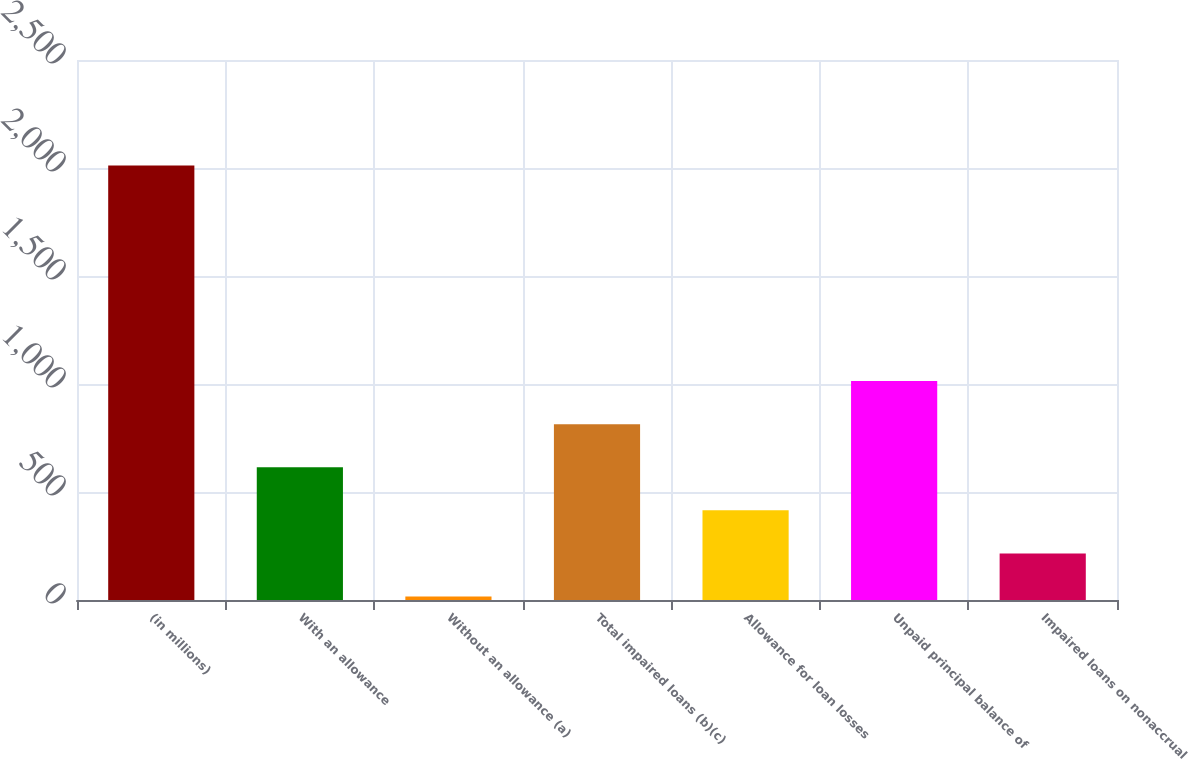Convert chart to OTSL. <chart><loc_0><loc_0><loc_500><loc_500><bar_chart><fcel>(in millions)<fcel>With an allowance<fcel>Without an allowance (a)<fcel>Total impaired loans (b)(c)<fcel>Allowance for loan losses<fcel>Unpaid principal balance of<fcel>Impaired loans on nonaccrual<nl><fcel>2011<fcel>614.5<fcel>16<fcel>814<fcel>415<fcel>1013.5<fcel>215.5<nl></chart> 